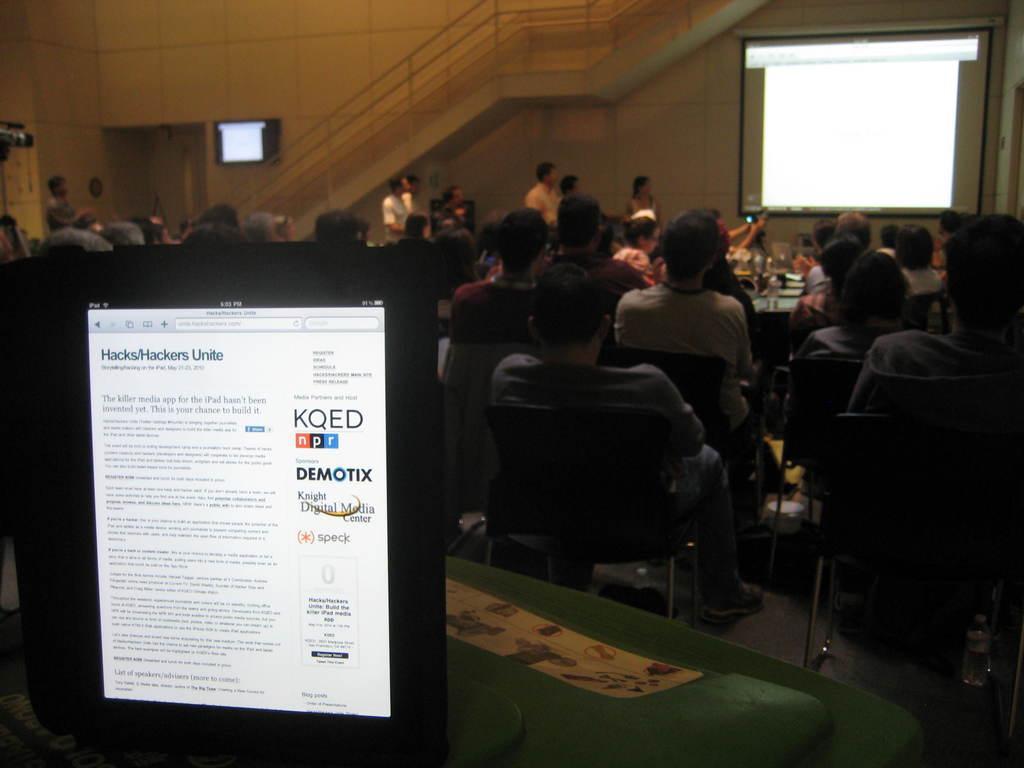Can you describe this image briefly? As we can see in the image there are few people here and there, table, screen, stairs and there is a wall. 